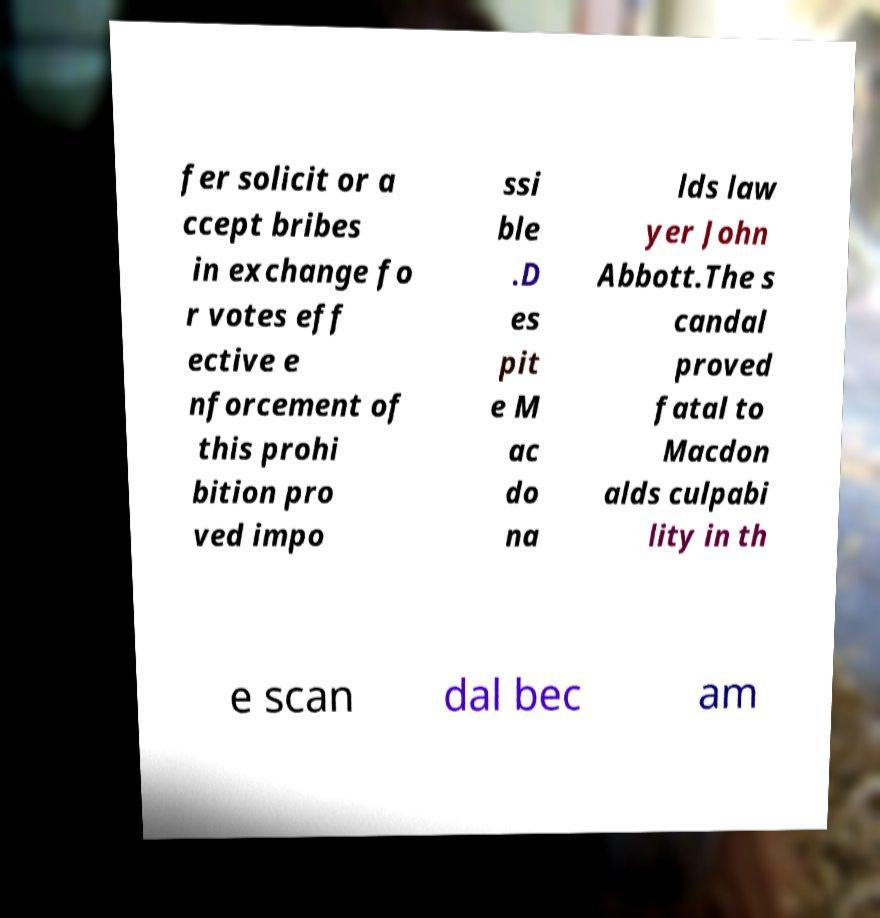There's text embedded in this image that I need extracted. Can you transcribe it verbatim? fer solicit or a ccept bribes in exchange fo r votes eff ective e nforcement of this prohi bition pro ved impo ssi ble .D es pit e M ac do na lds law yer John Abbott.The s candal proved fatal to Macdon alds culpabi lity in th e scan dal bec am 